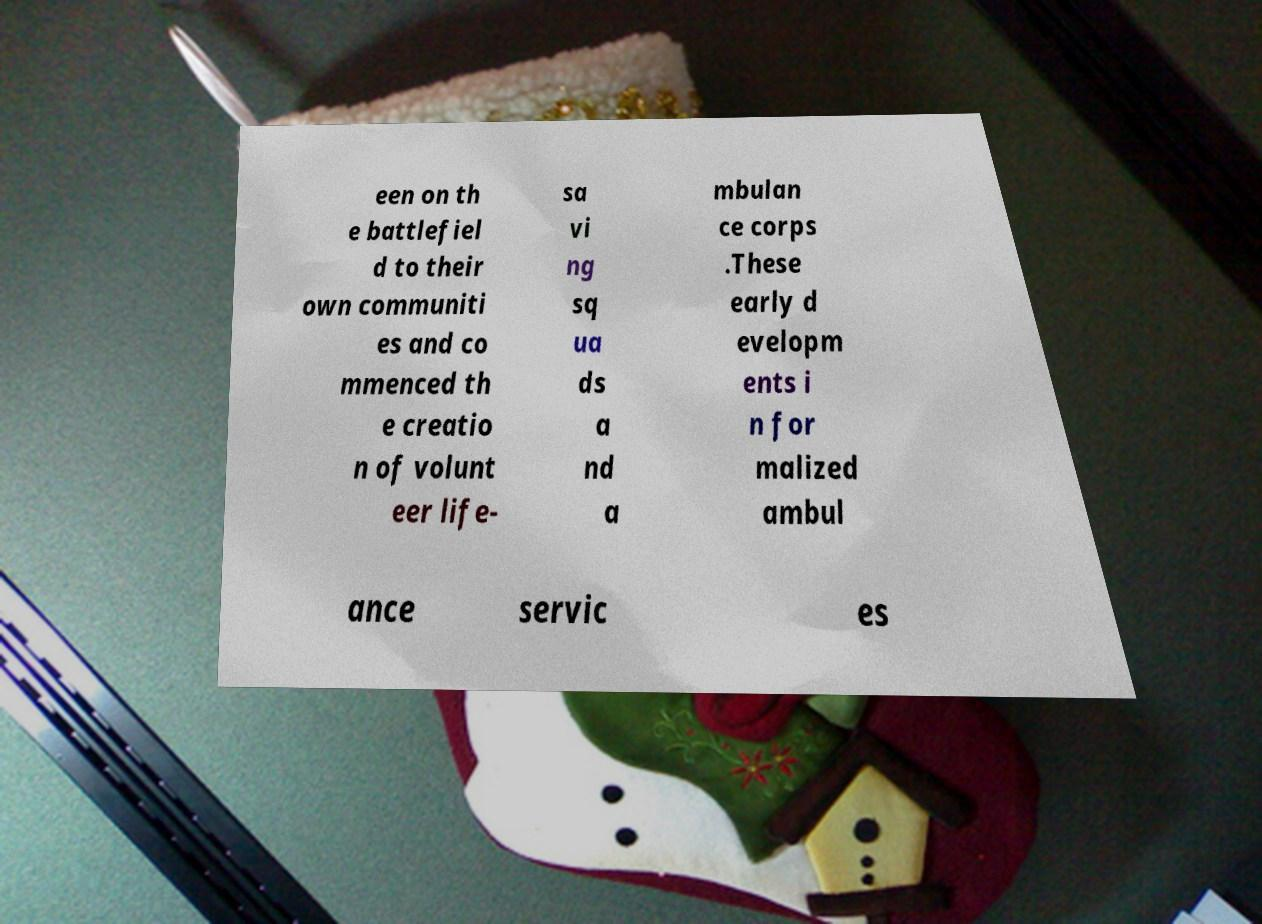Could you assist in decoding the text presented in this image and type it out clearly? een on th e battlefiel d to their own communiti es and co mmenced th e creatio n of volunt eer life- sa vi ng sq ua ds a nd a mbulan ce corps .These early d evelopm ents i n for malized ambul ance servic es 